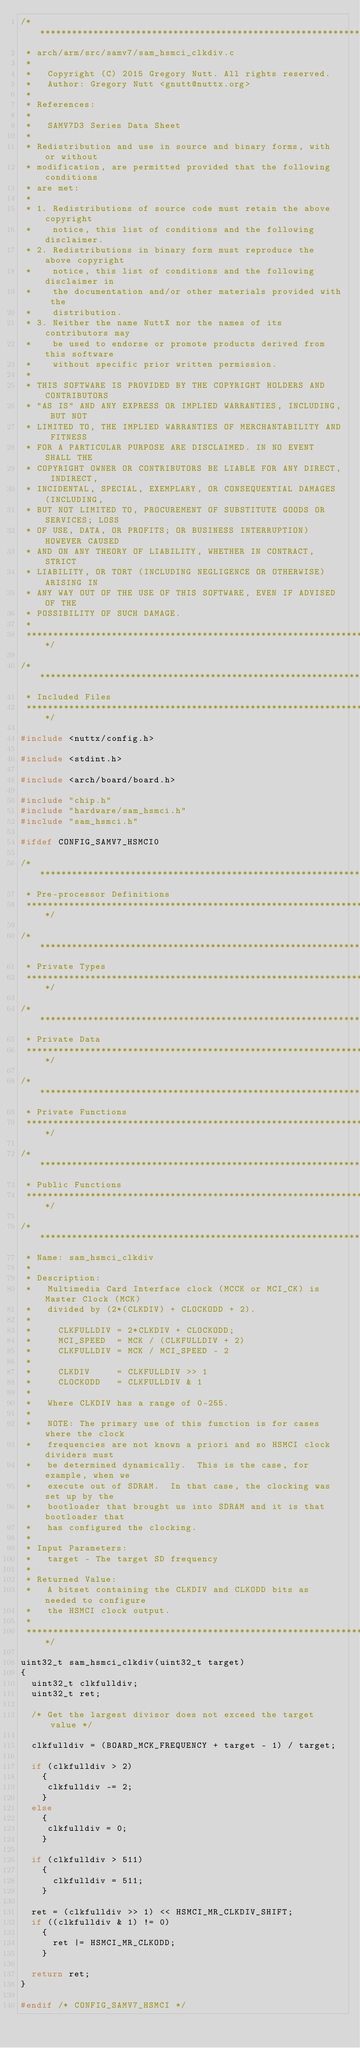<code> <loc_0><loc_0><loc_500><loc_500><_C_>/****************************************************************************
 * arch/arm/src/samv7/sam_hsmci_clkdiv.c
 *
 *   Copyright (C) 2015 Gregory Nutt. All rights reserved.
 *   Author: Gregory Nutt <gnutt@nuttx.org>
 *
 * References:
 *
 *   SAMV7D3 Series Data Sheet
 *
 * Redistribution and use in source and binary forms, with or without
 * modification, are permitted provided that the following conditions
 * are met:
 *
 * 1. Redistributions of source code must retain the above copyright
 *    notice, this list of conditions and the following disclaimer.
 * 2. Redistributions in binary form must reproduce the above copyright
 *    notice, this list of conditions and the following disclaimer in
 *    the documentation and/or other materials provided with the
 *    distribution.
 * 3. Neither the name NuttX nor the names of its contributors may
 *    be used to endorse or promote products derived from this software
 *    without specific prior written permission.
 *
 * THIS SOFTWARE IS PROVIDED BY THE COPYRIGHT HOLDERS AND CONTRIBUTORS
 * "AS IS" AND ANY EXPRESS OR IMPLIED WARRANTIES, INCLUDING, BUT NOT
 * LIMITED TO, THE IMPLIED WARRANTIES OF MERCHANTABILITY AND FITNESS
 * FOR A PARTICULAR PURPOSE ARE DISCLAIMED. IN NO EVENT SHALL THE
 * COPYRIGHT OWNER OR CONTRIBUTORS BE LIABLE FOR ANY DIRECT, INDIRECT,
 * INCIDENTAL, SPECIAL, EXEMPLARY, OR CONSEQUENTIAL DAMAGES (INCLUDING,
 * BUT NOT LIMITED TO, PROCUREMENT OF SUBSTITUTE GOODS OR SERVICES; LOSS
 * OF USE, DATA, OR PROFITS; OR BUSINESS INTERRUPTION) HOWEVER CAUSED
 * AND ON ANY THEORY OF LIABILITY, WHETHER IN CONTRACT, STRICT
 * LIABILITY, OR TORT (INCLUDING NEGLIGENCE OR OTHERWISE) ARISING IN
 * ANY WAY OUT OF THE USE OF THIS SOFTWARE, EVEN IF ADVISED OF THE
 * POSSIBILITY OF SUCH DAMAGE.
 *
 ****************************************************************************/

/****************************************************************************
 * Included Files
 ****************************************************************************/

#include <nuttx/config.h>

#include <stdint.h>

#include <arch/board/board.h>

#include "chip.h"
#include "hardware/sam_hsmci.h"
#include "sam_hsmci.h"

#ifdef CONFIG_SAMV7_HSMCI0

/****************************************************************************
 * Pre-processor Definitions
 ****************************************************************************/

/****************************************************************************
 * Private Types
 ****************************************************************************/

/****************************************************************************
 * Private Data
 ****************************************************************************/

/****************************************************************************
 * Private Functions
 ****************************************************************************/

/****************************************************************************
 * Public Functions
 ****************************************************************************/

/****************************************************************************
 * Name: sam_hsmci_clkdiv
 *
 * Description:
 *   Multimedia Card Interface clock (MCCK or MCI_CK) is Master Clock (MCK)
 *   divided by (2*(CLKDIV) + CLOCKODD + 2).
 *
 *     CLKFULLDIV = 2*CLKDIV + CLOCKODD;
 *     MCI_SPEED  = MCK / (CLKFULLDIV + 2)
 *     CLKFULLDIV = MCK / MCI_SPEED - 2
 *
 *     CLKDIV     = CLKFULLDIV >> 1
 *     CLOCKODD   = CLKFULLDIV & 1
 *
 *   Where CLKDIV has a range of 0-255.
 *
 *   NOTE: The primary use of this function is for cases where the clock
 *   frequencies are not known a priori and so HSMCI clock dividers must
 *   be determined dynamically.  This is the case, for example, when we
 *   execute out of SDRAM.  In that case, the clocking was set up by the
 *   bootloader that brought us into SDRAM and it is that bootloader that
 *   has configured the clocking.
 *
 * Input Parameters:
 *   target - The target SD frequency
 *
 * Returned Value:
 *   A bitset containing the CLKDIV and CLKODD bits as needed to configure
 *   the HSMCI clock output.
 *
 ****************************************************************************/

uint32_t sam_hsmci_clkdiv(uint32_t target)
{
  uint32_t clkfulldiv;
  uint32_t ret;

  /* Get the largest divisor does not exceed the target value */

  clkfulldiv = (BOARD_MCK_FREQUENCY + target - 1) / target;

  if (clkfulldiv > 2)
    {
     clkfulldiv -= 2;
    }
  else
    {
     clkfulldiv = 0;
    }

  if (clkfulldiv > 511)
    {
      clkfulldiv = 511;
    }

  ret = (clkfulldiv >> 1) << HSMCI_MR_CLKDIV_SHIFT;
  if ((clkfulldiv & 1) != 0)
    {
      ret |= HSMCI_MR_CLKODD;
    }

  return ret;
}

#endif /* CONFIG_SAMV7_HSMCI */
</code> 